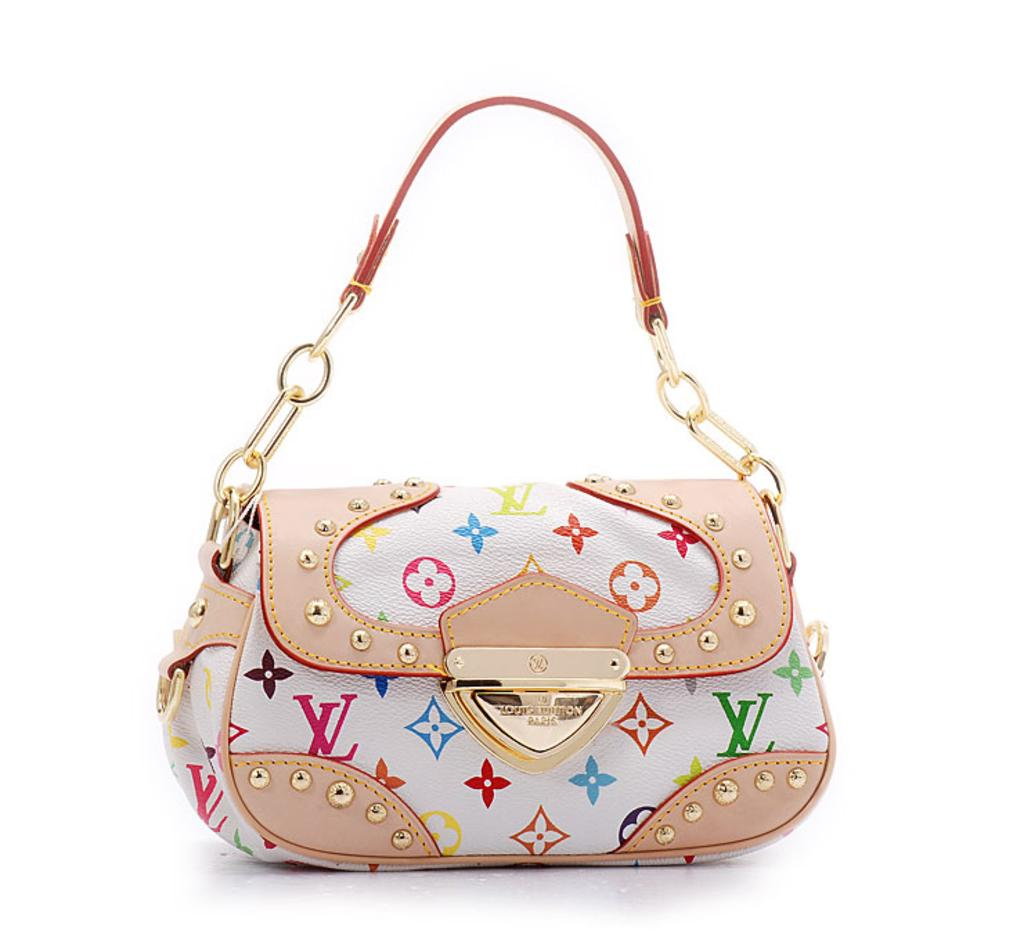What object is present in the image that can be used to carry items? There is a bag in the image that can be used to carry items. What feature is attached to the bag? The bag has a chain. What colors can be seen on the bag? The bag's color is white and peach. Can you see the chin of the person holding the bag in the image? There is no person holding the bag in the image, so it is not possible to see their chin. 